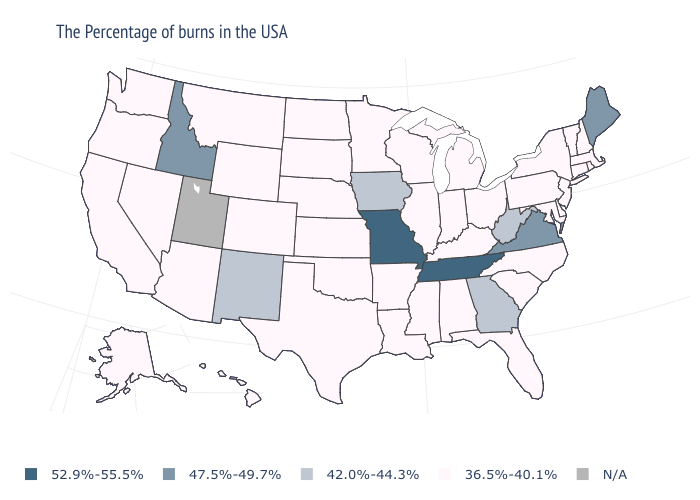What is the lowest value in the West?
Quick response, please. 36.5%-40.1%. Is the legend a continuous bar?
Give a very brief answer. No. Does Tennessee have the highest value in the South?
Be succinct. Yes. Name the states that have a value in the range 47.5%-49.7%?
Quick response, please. Maine, Virginia, Idaho. Name the states that have a value in the range 52.9%-55.5%?
Answer briefly. Tennessee, Missouri. Name the states that have a value in the range 42.0%-44.3%?
Give a very brief answer. West Virginia, Georgia, Iowa, New Mexico. How many symbols are there in the legend?
Answer briefly. 5. What is the value of Washington?
Concise answer only. 36.5%-40.1%. Name the states that have a value in the range N/A?
Be succinct. Utah. Name the states that have a value in the range N/A?
Write a very short answer. Utah. Name the states that have a value in the range 36.5%-40.1%?
Quick response, please. Massachusetts, Rhode Island, New Hampshire, Vermont, Connecticut, New York, New Jersey, Delaware, Maryland, Pennsylvania, North Carolina, South Carolina, Ohio, Florida, Michigan, Kentucky, Indiana, Alabama, Wisconsin, Illinois, Mississippi, Louisiana, Arkansas, Minnesota, Kansas, Nebraska, Oklahoma, Texas, South Dakota, North Dakota, Wyoming, Colorado, Montana, Arizona, Nevada, California, Washington, Oregon, Alaska, Hawaii. Name the states that have a value in the range N/A?
Write a very short answer. Utah. Does Missouri have the highest value in the USA?
Concise answer only. Yes. 